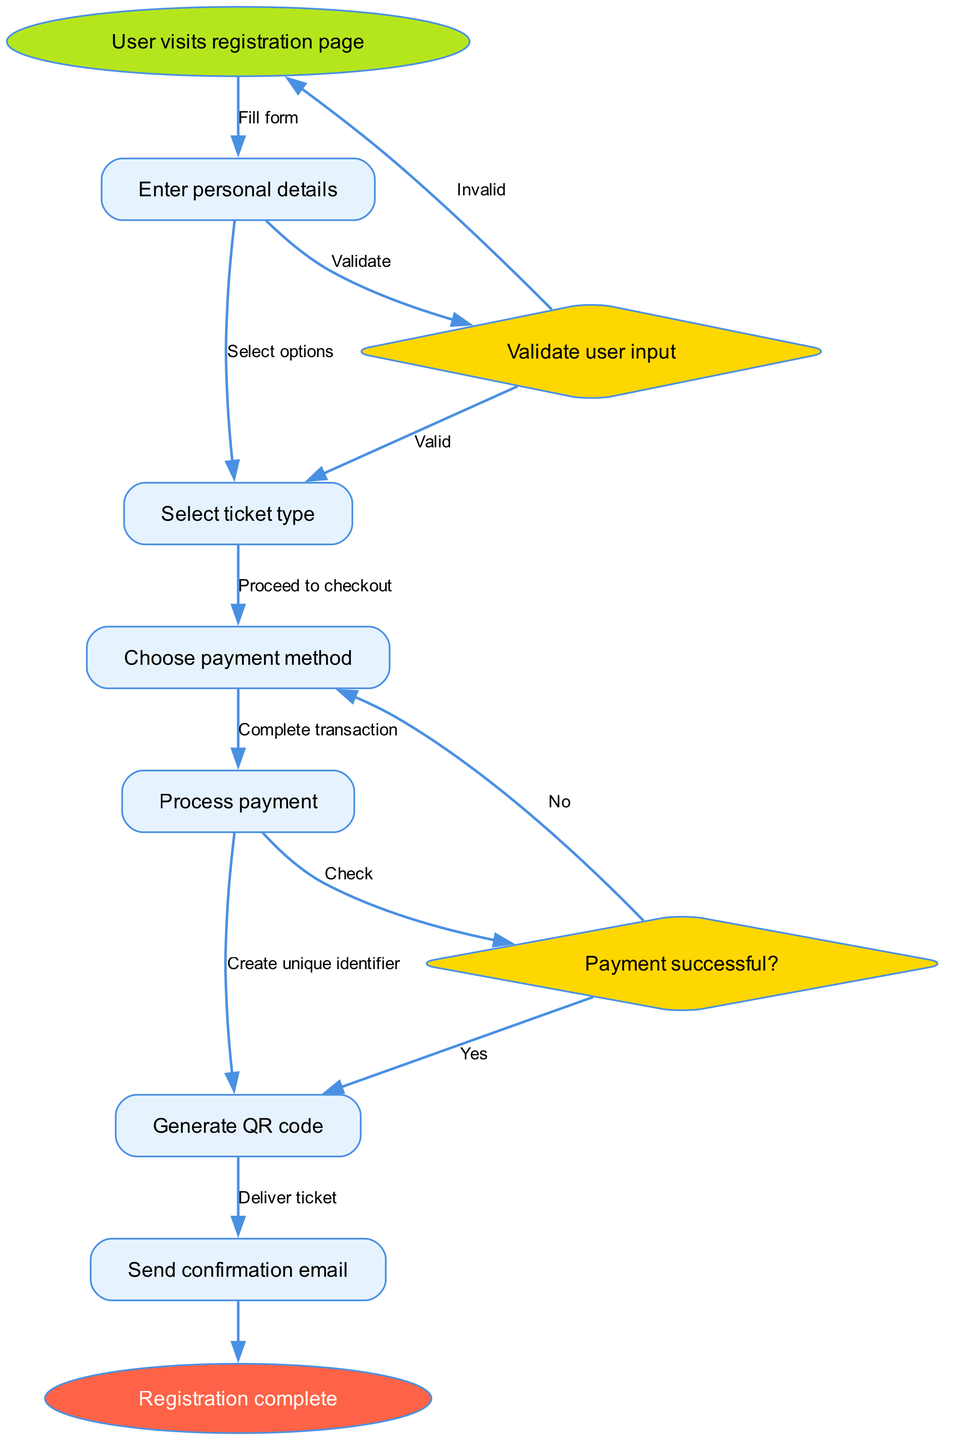What is the starting point of the user registration process? The starting point is the first node in the flowchart, which indicates where the process begins: "User visits registration page."
Answer: User visits registration page How many decision nodes are present in the diagram? There are two decision nodes in the flowchart: "Validate user input" and "Payment successful?" By counting them, we determine the total number.
Answer: 2 What happens if the user input is invalid? Referring to the decision node for validation, if the user input is invalid, the flow leads back to the starting point, indicating the user should try again.
Answer: Return to start What is generated after processing the payment? Following the flow of the diagram, once the payment is processed, the next step is generating a QR code for the user, which is indicated by the subsequent node.
Answer: Generate QR code What edge connects the "Choose payment method" node to "Process payment"? The edge between these two nodes is labeled "Proceed to checkout," which signifies the action taken to move from selecting a payment method to processing the payment.
Answer: Proceed to checkout What would happen if the payment is not successful? According to the flowchart, if the payment is not successful, the process will lead to the option for the user to select another payment method, as indicated in the edge connections leading out of the payment decision node.
Answer: Select another payment method What action is taken at the end of the registration process? The final action in the flowchart is reflected in the end node, which indicates that the registration process concludes with a confirmation that the user’s registration is complete.
Answer: Registration complete In which step does the user enter their personal details? The user enters personal details in the second step of the flowchart after visiting the registration page, which is clearly described in the flow of the nodes.
Answer: Enter personal details What label is provided for the edge leading from "Validate user input" to "Select ticket type"? The edge connecting these nodes is labeled "Valid," indicating that the flow continues if the user input is validated successfully.
Answer: Valid 